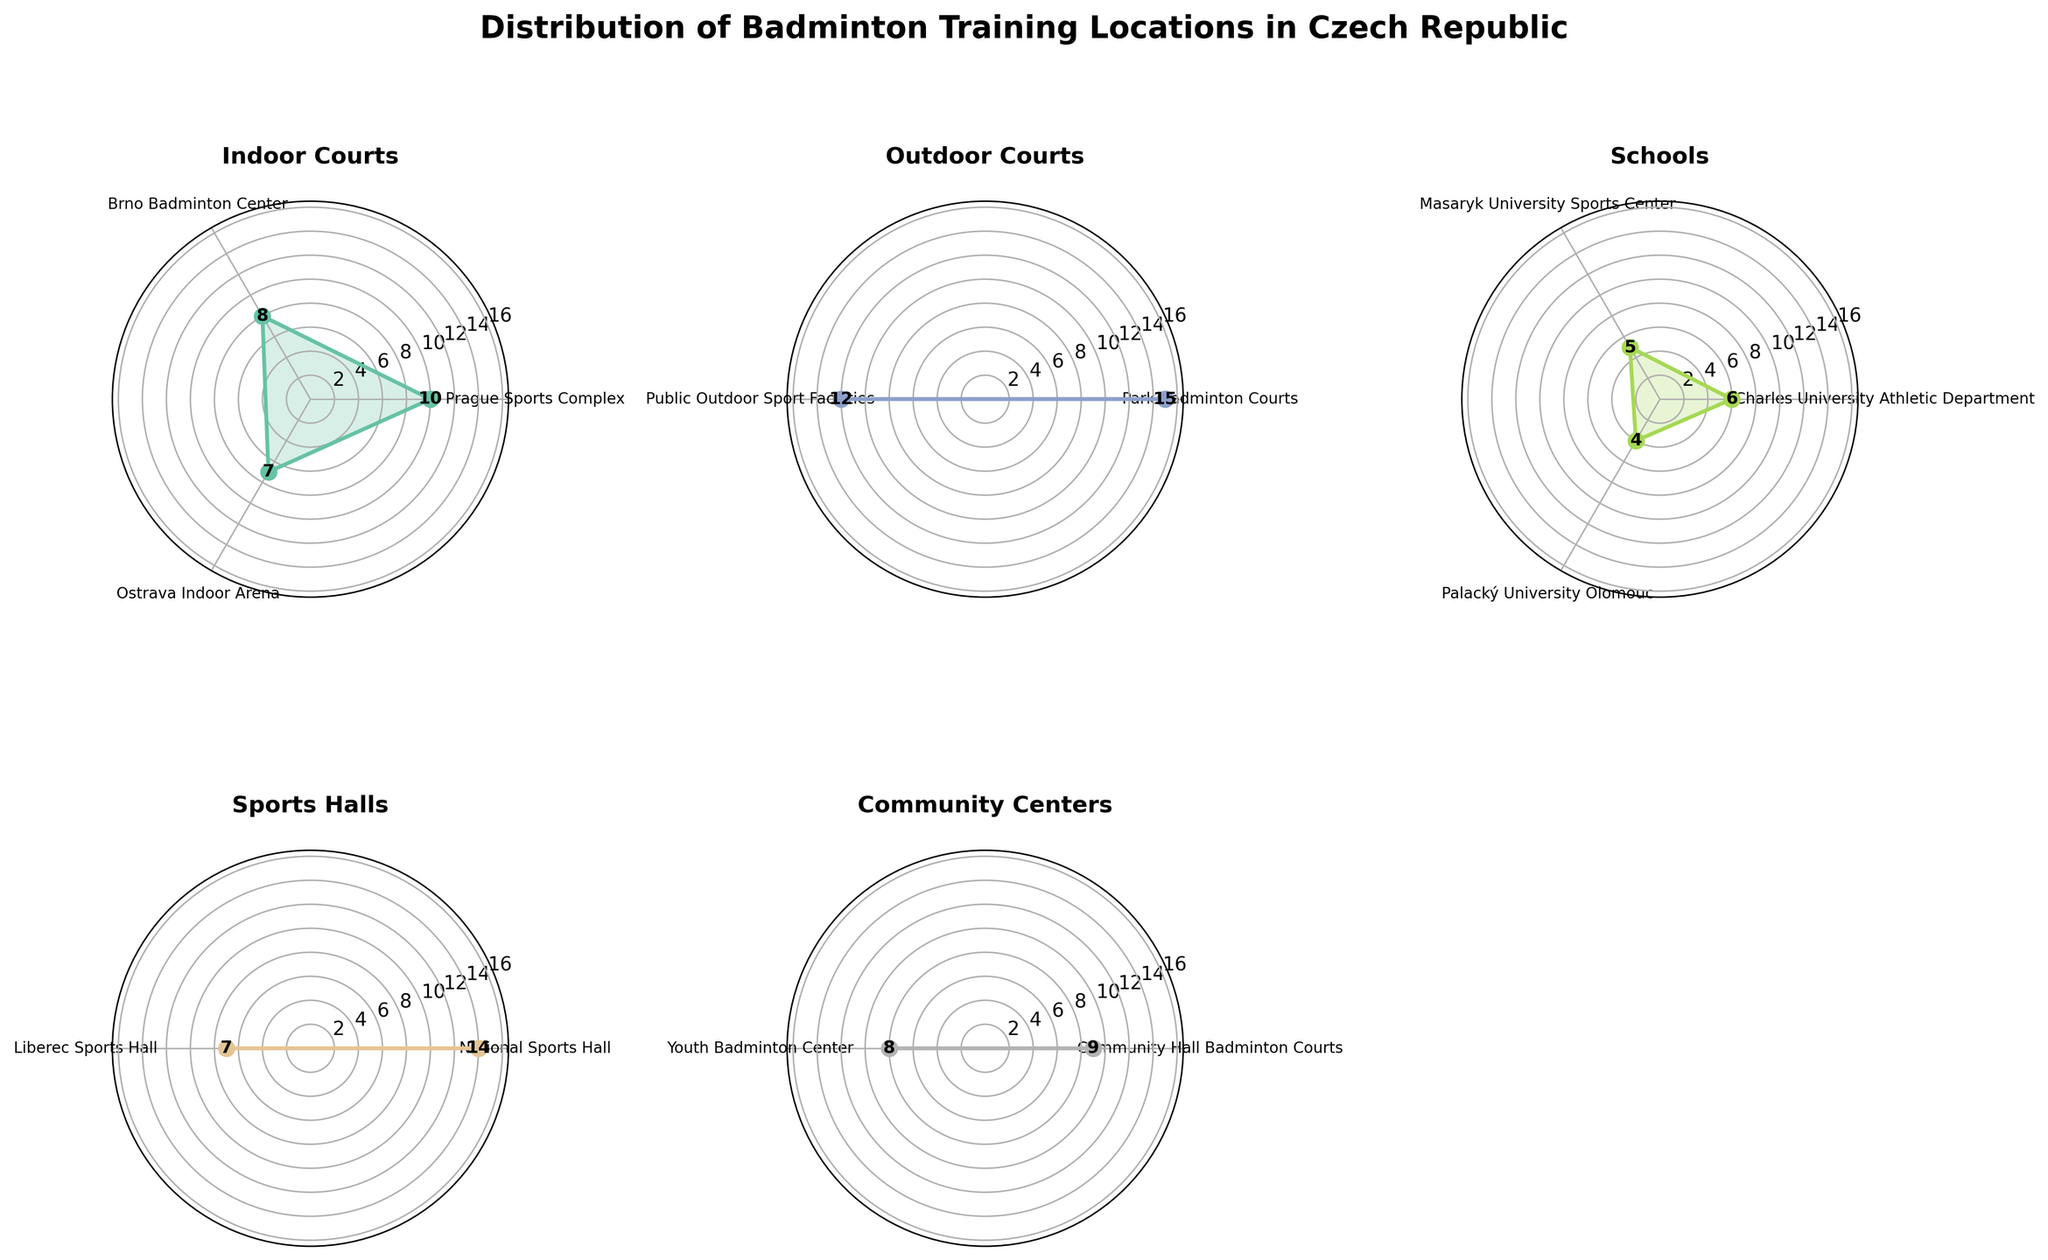what is the title of the chart? The title is usually found at the top of the chart. In this case, it states: 'Distribution of Badminton Training Locations in Czech Republic'.
Answer: Distribution of Badminton Training Locations in Czech Republic Which indoor court location has the highest count of training locations? Look at the subplot for 'Indoor Courts' and identify the label with the highest value. The peak value on the chart corresponds to 'Prague Sports Complex' with a count of 10.
Answer: Prague Sports Complex How many training locations are there in total across all community centers? Sum the values shown for community centers by looking at the 'Community Hall Badminton Courts' and 'Youth Badminton Center'. They have counts of 9 and 8 respectively, so 9 + 8 = 17.
Answer: 17 What type of training location has the highest single count? Look across all the subplots and identify the highest value among all location types. 'Outdoor Courts' at 'Park Badminton Courts' has the highest single count of 15.
Answer: Outdoor Courts Which has more training locations: schools or sports halls? Sum the values for schools and sports halls separately and compare the totals. Schools: 6+5+4 = 15; Sports Halls: 14+7 = 21. Sports halls have more training locations than schools.
Answer: Sports Halls What is the average number of training locations for outdoor courts? Calculate the average by summing the number of locations for outdoor courts and then dividing by the number of locations. (15+12) / 2 = 13.5.
Answer: 13.5 Which location type has the second highest total count of training locations? Sum the counts for each location type and identify the second highest total. Indoor Courts: 10+8+7 = 25; Outdoor Courts: 15+12 = 27; Schools: 6+5+4 = 15; Sports Halls: 14+7 = 21; Community Centers: 9+8 = 17. Indoor Courts, with a count of 25, is second highest.
Answer: Indoor Courts What is the minimum count of training locations for a single community center? Look at the subplot for 'Community Centers' and identify the smallest value. 'Youth Badminton Center' has the smallest count with 8.
Answer: 8 